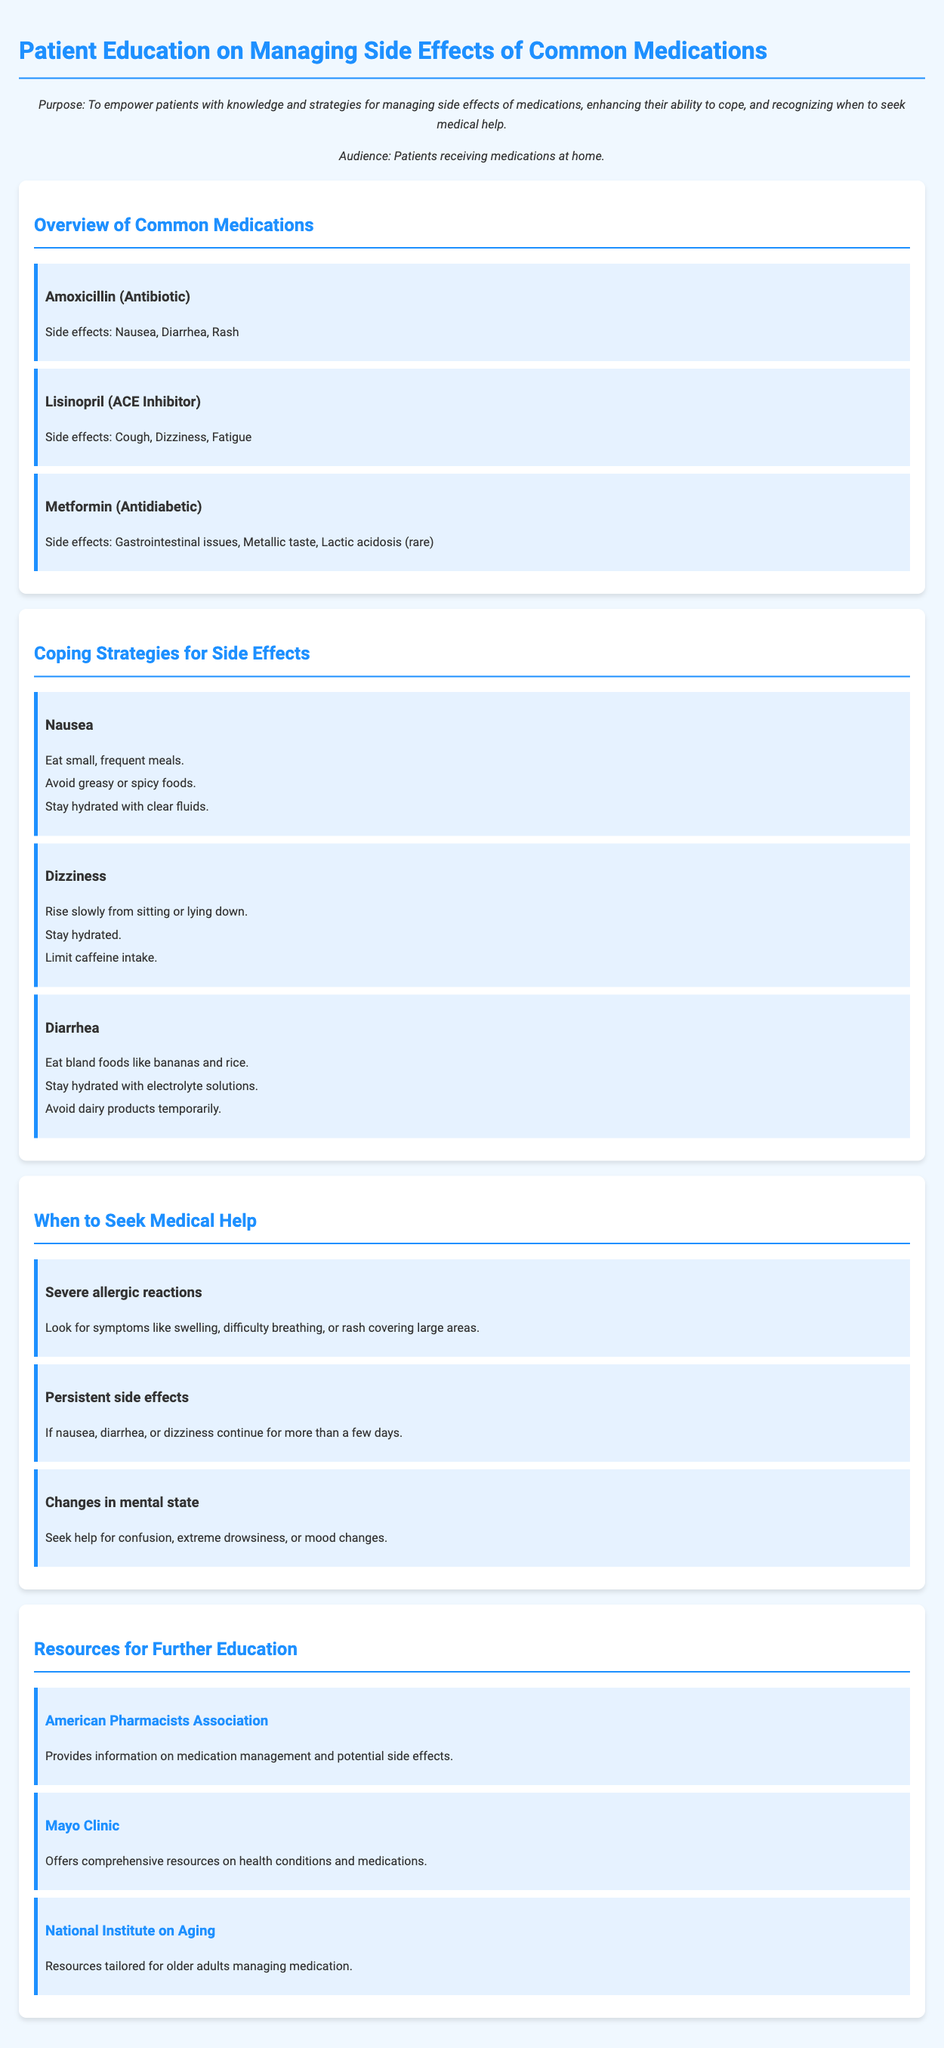What are the side effects of Amoxicillin? The document lists nausea, diarrhea, and rash as side effects of Amoxicillin.
Answer: Nausea, Diarrhea, Rash What coping strategy is suggested for diarrhea? The document recommends eating bland foods like bananas and rice for diarrhea.
Answer: Eat bland foods What is a severe allergic reaction symptom mentioned? The document states that symptoms include swelling, difficulty breathing, or rash covering large areas.
Answer: Swelling How should one manage dizziness according to coping strategies? The document advises rising slowly from sitting or lying down as a way to manage dizziness.
Answer: Rise slowly What website offers information on medication management? The document includes the American Pharmacists Association website for information on medication management.
Answer: American Pharmacists Association What common medication has gastrointestinal issues as a side effect? According to the document, Metformin has gastrointestinal issues as a side effect.
Answer: Metformin When should a patient seek medical help for persistent side effects? The document specifies seeking help if nausea, diarrhea, or dizziness continue for more than a few days.
Answer: More than a few days What age group is specifically targeted in the resources section? The document mentions that the National Institute on Aging provides resources tailored for older adults.
Answer: Older adults 